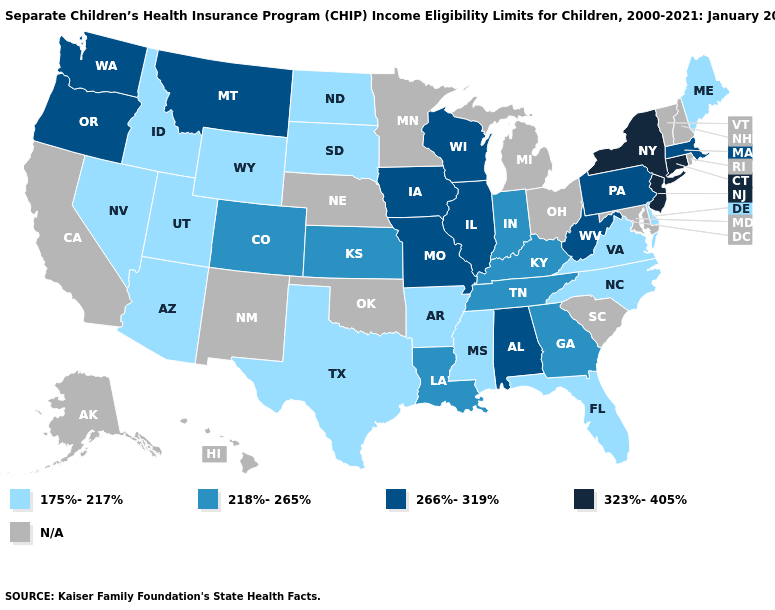What is the value of Ohio?
Quick response, please. N/A. Name the states that have a value in the range 218%-265%?
Write a very short answer. Colorado, Georgia, Indiana, Kansas, Kentucky, Louisiana, Tennessee. Which states have the lowest value in the West?
Keep it brief. Arizona, Idaho, Nevada, Utah, Wyoming. Among the states that border Maryland , does Delaware have the lowest value?
Keep it brief. Yes. What is the value of South Carolina?
Quick response, please. N/A. What is the value of New York?
Keep it brief. 323%-405%. Which states have the highest value in the USA?
Write a very short answer. Connecticut, New Jersey, New York. Does Connecticut have the highest value in the USA?
Be succinct. Yes. What is the value of Washington?
Concise answer only. 266%-319%. What is the value of Pennsylvania?
Be succinct. 266%-319%. Does New York have the highest value in the USA?
Answer briefly. Yes. Name the states that have a value in the range 218%-265%?
Concise answer only. Colorado, Georgia, Indiana, Kansas, Kentucky, Louisiana, Tennessee. Name the states that have a value in the range 323%-405%?
Answer briefly. Connecticut, New Jersey, New York. What is the highest value in states that border Alabama?
Keep it brief. 218%-265%. 